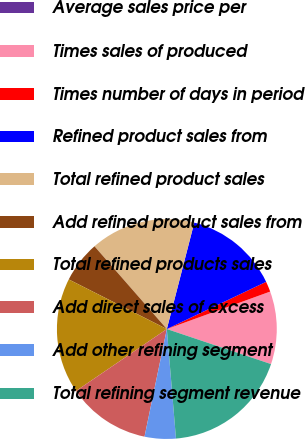Convert chart. <chart><loc_0><loc_0><loc_500><loc_500><pie_chart><fcel>Average sales price per<fcel>Times sales of produced<fcel>Times number of days in period<fcel>Refined product sales from<fcel>Total refined product sales<fcel>Add refined product sales from<fcel>Total refined products sales<fcel>Add direct sales of excess<fcel>Add other refining segment<fcel>Total refining segment revenue<nl><fcel>0.0%<fcel>10.7%<fcel>1.53%<fcel>13.92%<fcel>15.45%<fcel>6.11%<fcel>16.98%<fcel>12.22%<fcel>4.58%<fcel>18.51%<nl></chart> 